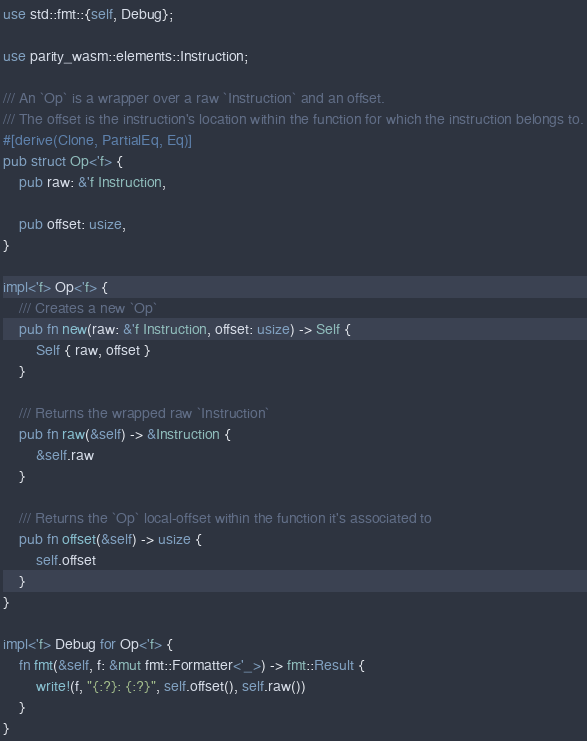<code> <loc_0><loc_0><loc_500><loc_500><_Rust_>use std::fmt::{self, Debug};

use parity_wasm::elements::Instruction;

/// An `Op` is a wrapper over a raw `Instruction` and an offset.
/// The offset is the instruction's location within the function for which the instruction belongs to.
#[derive(Clone, PartialEq, Eq)]
pub struct Op<'f> {
    pub raw: &'f Instruction,

    pub offset: usize,
}

impl<'f> Op<'f> {
    /// Creates a new `Op`
    pub fn new(raw: &'f Instruction, offset: usize) -> Self {
        Self { raw, offset }
    }

    /// Returns the wrapped raw `Instruction`
    pub fn raw(&self) -> &Instruction {
        &self.raw
    }

    /// Returns the `Op` local-offset within the function it's associated to
    pub fn offset(&self) -> usize {
        self.offset
    }
}

impl<'f> Debug for Op<'f> {
    fn fmt(&self, f: &mut fmt::Formatter<'_>) -> fmt::Result {
        write!(f, "{:?}: {:?}", self.offset(), self.raw())
    }
}
</code> 